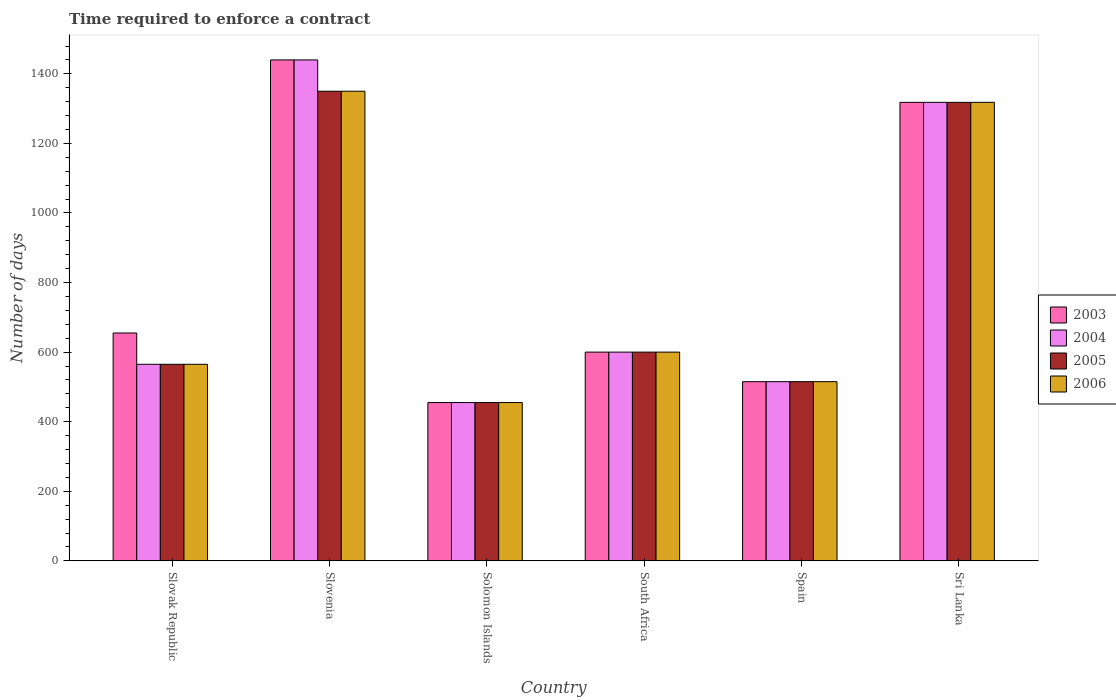Are the number of bars on each tick of the X-axis equal?
Make the answer very short. Yes. What is the label of the 4th group of bars from the left?
Offer a terse response. South Africa. In how many cases, is the number of bars for a given country not equal to the number of legend labels?
Make the answer very short. 0. What is the number of days required to enforce a contract in 2004 in Solomon Islands?
Your response must be concise. 455. Across all countries, what is the maximum number of days required to enforce a contract in 2003?
Offer a terse response. 1440. Across all countries, what is the minimum number of days required to enforce a contract in 2005?
Your answer should be compact. 455. In which country was the number of days required to enforce a contract in 2003 maximum?
Your answer should be very brief. Slovenia. In which country was the number of days required to enforce a contract in 2006 minimum?
Provide a succinct answer. Solomon Islands. What is the total number of days required to enforce a contract in 2004 in the graph?
Keep it short and to the point. 4893. What is the difference between the number of days required to enforce a contract in 2003 in Slovenia and that in South Africa?
Provide a succinct answer. 840. What is the difference between the number of days required to enforce a contract in 2005 in Sri Lanka and the number of days required to enforce a contract in 2004 in South Africa?
Make the answer very short. 718. What is the average number of days required to enforce a contract in 2004 per country?
Provide a short and direct response. 815.5. In how many countries, is the number of days required to enforce a contract in 2004 greater than 1360 days?
Offer a very short reply. 1. What is the ratio of the number of days required to enforce a contract in 2003 in Slovak Republic to that in South Africa?
Offer a very short reply. 1.09. Is the number of days required to enforce a contract in 2006 in South Africa less than that in Spain?
Offer a very short reply. No. Is the difference between the number of days required to enforce a contract in 2005 in Slovak Republic and Sri Lanka greater than the difference between the number of days required to enforce a contract in 2004 in Slovak Republic and Sri Lanka?
Make the answer very short. No. What is the difference between the highest and the second highest number of days required to enforce a contract in 2006?
Provide a succinct answer. 718. What is the difference between the highest and the lowest number of days required to enforce a contract in 2006?
Give a very brief answer. 895. Is the sum of the number of days required to enforce a contract in 2005 in Spain and Sri Lanka greater than the maximum number of days required to enforce a contract in 2003 across all countries?
Provide a succinct answer. Yes. Is it the case that in every country, the sum of the number of days required to enforce a contract in 2006 and number of days required to enforce a contract in 2005 is greater than the number of days required to enforce a contract in 2004?
Make the answer very short. Yes. How many countries are there in the graph?
Your answer should be compact. 6. What is the difference between two consecutive major ticks on the Y-axis?
Your answer should be very brief. 200. Are the values on the major ticks of Y-axis written in scientific E-notation?
Your answer should be compact. No. Where does the legend appear in the graph?
Give a very brief answer. Center right. How are the legend labels stacked?
Make the answer very short. Vertical. What is the title of the graph?
Offer a terse response. Time required to enforce a contract. What is the label or title of the X-axis?
Offer a terse response. Country. What is the label or title of the Y-axis?
Offer a very short reply. Number of days. What is the Number of days of 2003 in Slovak Republic?
Offer a very short reply. 655. What is the Number of days of 2004 in Slovak Republic?
Give a very brief answer. 565. What is the Number of days in 2005 in Slovak Republic?
Your response must be concise. 565. What is the Number of days of 2006 in Slovak Republic?
Give a very brief answer. 565. What is the Number of days of 2003 in Slovenia?
Offer a terse response. 1440. What is the Number of days of 2004 in Slovenia?
Give a very brief answer. 1440. What is the Number of days in 2005 in Slovenia?
Ensure brevity in your answer.  1350. What is the Number of days in 2006 in Slovenia?
Offer a terse response. 1350. What is the Number of days in 2003 in Solomon Islands?
Ensure brevity in your answer.  455. What is the Number of days in 2004 in Solomon Islands?
Give a very brief answer. 455. What is the Number of days of 2005 in Solomon Islands?
Ensure brevity in your answer.  455. What is the Number of days of 2006 in Solomon Islands?
Offer a terse response. 455. What is the Number of days of 2003 in South Africa?
Your answer should be very brief. 600. What is the Number of days of 2004 in South Africa?
Give a very brief answer. 600. What is the Number of days in 2005 in South Africa?
Make the answer very short. 600. What is the Number of days of 2006 in South Africa?
Keep it short and to the point. 600. What is the Number of days in 2003 in Spain?
Provide a succinct answer. 515. What is the Number of days in 2004 in Spain?
Provide a succinct answer. 515. What is the Number of days in 2005 in Spain?
Keep it short and to the point. 515. What is the Number of days of 2006 in Spain?
Make the answer very short. 515. What is the Number of days of 2003 in Sri Lanka?
Your response must be concise. 1318. What is the Number of days in 2004 in Sri Lanka?
Ensure brevity in your answer.  1318. What is the Number of days of 2005 in Sri Lanka?
Ensure brevity in your answer.  1318. What is the Number of days in 2006 in Sri Lanka?
Offer a very short reply. 1318. Across all countries, what is the maximum Number of days in 2003?
Keep it short and to the point. 1440. Across all countries, what is the maximum Number of days in 2004?
Provide a succinct answer. 1440. Across all countries, what is the maximum Number of days of 2005?
Make the answer very short. 1350. Across all countries, what is the maximum Number of days in 2006?
Ensure brevity in your answer.  1350. Across all countries, what is the minimum Number of days in 2003?
Offer a terse response. 455. Across all countries, what is the minimum Number of days of 2004?
Provide a short and direct response. 455. Across all countries, what is the minimum Number of days of 2005?
Your response must be concise. 455. Across all countries, what is the minimum Number of days of 2006?
Ensure brevity in your answer.  455. What is the total Number of days of 2003 in the graph?
Make the answer very short. 4983. What is the total Number of days in 2004 in the graph?
Offer a very short reply. 4893. What is the total Number of days of 2005 in the graph?
Your answer should be compact. 4803. What is the total Number of days in 2006 in the graph?
Ensure brevity in your answer.  4803. What is the difference between the Number of days of 2003 in Slovak Republic and that in Slovenia?
Keep it short and to the point. -785. What is the difference between the Number of days of 2004 in Slovak Republic and that in Slovenia?
Ensure brevity in your answer.  -875. What is the difference between the Number of days in 2005 in Slovak Republic and that in Slovenia?
Ensure brevity in your answer.  -785. What is the difference between the Number of days of 2006 in Slovak Republic and that in Slovenia?
Your response must be concise. -785. What is the difference between the Number of days in 2003 in Slovak Republic and that in Solomon Islands?
Keep it short and to the point. 200. What is the difference between the Number of days of 2004 in Slovak Republic and that in Solomon Islands?
Keep it short and to the point. 110. What is the difference between the Number of days in 2005 in Slovak Republic and that in Solomon Islands?
Your response must be concise. 110. What is the difference between the Number of days of 2006 in Slovak Republic and that in Solomon Islands?
Your answer should be very brief. 110. What is the difference between the Number of days of 2004 in Slovak Republic and that in South Africa?
Offer a very short reply. -35. What is the difference between the Number of days of 2005 in Slovak Republic and that in South Africa?
Offer a very short reply. -35. What is the difference between the Number of days in 2006 in Slovak Republic and that in South Africa?
Your answer should be compact. -35. What is the difference between the Number of days of 2003 in Slovak Republic and that in Spain?
Your answer should be compact. 140. What is the difference between the Number of days in 2005 in Slovak Republic and that in Spain?
Your answer should be compact. 50. What is the difference between the Number of days in 2006 in Slovak Republic and that in Spain?
Provide a short and direct response. 50. What is the difference between the Number of days of 2003 in Slovak Republic and that in Sri Lanka?
Give a very brief answer. -663. What is the difference between the Number of days in 2004 in Slovak Republic and that in Sri Lanka?
Ensure brevity in your answer.  -753. What is the difference between the Number of days of 2005 in Slovak Republic and that in Sri Lanka?
Ensure brevity in your answer.  -753. What is the difference between the Number of days in 2006 in Slovak Republic and that in Sri Lanka?
Provide a short and direct response. -753. What is the difference between the Number of days in 2003 in Slovenia and that in Solomon Islands?
Provide a succinct answer. 985. What is the difference between the Number of days of 2004 in Slovenia and that in Solomon Islands?
Offer a terse response. 985. What is the difference between the Number of days in 2005 in Slovenia and that in Solomon Islands?
Give a very brief answer. 895. What is the difference between the Number of days of 2006 in Slovenia and that in Solomon Islands?
Your answer should be very brief. 895. What is the difference between the Number of days of 2003 in Slovenia and that in South Africa?
Keep it short and to the point. 840. What is the difference between the Number of days in 2004 in Slovenia and that in South Africa?
Your response must be concise. 840. What is the difference between the Number of days in 2005 in Slovenia and that in South Africa?
Your answer should be compact. 750. What is the difference between the Number of days in 2006 in Slovenia and that in South Africa?
Give a very brief answer. 750. What is the difference between the Number of days in 2003 in Slovenia and that in Spain?
Ensure brevity in your answer.  925. What is the difference between the Number of days of 2004 in Slovenia and that in Spain?
Provide a short and direct response. 925. What is the difference between the Number of days of 2005 in Slovenia and that in Spain?
Your answer should be compact. 835. What is the difference between the Number of days in 2006 in Slovenia and that in Spain?
Your answer should be very brief. 835. What is the difference between the Number of days of 2003 in Slovenia and that in Sri Lanka?
Make the answer very short. 122. What is the difference between the Number of days of 2004 in Slovenia and that in Sri Lanka?
Offer a terse response. 122. What is the difference between the Number of days in 2005 in Slovenia and that in Sri Lanka?
Offer a very short reply. 32. What is the difference between the Number of days in 2003 in Solomon Islands and that in South Africa?
Offer a very short reply. -145. What is the difference between the Number of days of 2004 in Solomon Islands and that in South Africa?
Provide a short and direct response. -145. What is the difference between the Number of days in 2005 in Solomon Islands and that in South Africa?
Provide a succinct answer. -145. What is the difference between the Number of days in 2006 in Solomon Islands and that in South Africa?
Keep it short and to the point. -145. What is the difference between the Number of days of 2003 in Solomon Islands and that in Spain?
Offer a very short reply. -60. What is the difference between the Number of days in 2004 in Solomon Islands and that in Spain?
Offer a very short reply. -60. What is the difference between the Number of days in 2005 in Solomon Islands and that in Spain?
Your answer should be very brief. -60. What is the difference between the Number of days of 2006 in Solomon Islands and that in Spain?
Provide a short and direct response. -60. What is the difference between the Number of days of 2003 in Solomon Islands and that in Sri Lanka?
Your response must be concise. -863. What is the difference between the Number of days of 2004 in Solomon Islands and that in Sri Lanka?
Ensure brevity in your answer.  -863. What is the difference between the Number of days of 2005 in Solomon Islands and that in Sri Lanka?
Provide a short and direct response. -863. What is the difference between the Number of days in 2006 in Solomon Islands and that in Sri Lanka?
Keep it short and to the point. -863. What is the difference between the Number of days of 2006 in South Africa and that in Spain?
Make the answer very short. 85. What is the difference between the Number of days in 2003 in South Africa and that in Sri Lanka?
Make the answer very short. -718. What is the difference between the Number of days of 2004 in South Africa and that in Sri Lanka?
Ensure brevity in your answer.  -718. What is the difference between the Number of days of 2005 in South Africa and that in Sri Lanka?
Your answer should be compact. -718. What is the difference between the Number of days of 2006 in South Africa and that in Sri Lanka?
Ensure brevity in your answer.  -718. What is the difference between the Number of days of 2003 in Spain and that in Sri Lanka?
Provide a short and direct response. -803. What is the difference between the Number of days in 2004 in Spain and that in Sri Lanka?
Ensure brevity in your answer.  -803. What is the difference between the Number of days in 2005 in Spain and that in Sri Lanka?
Offer a terse response. -803. What is the difference between the Number of days of 2006 in Spain and that in Sri Lanka?
Your response must be concise. -803. What is the difference between the Number of days of 2003 in Slovak Republic and the Number of days of 2004 in Slovenia?
Keep it short and to the point. -785. What is the difference between the Number of days of 2003 in Slovak Republic and the Number of days of 2005 in Slovenia?
Your answer should be very brief. -695. What is the difference between the Number of days in 2003 in Slovak Republic and the Number of days in 2006 in Slovenia?
Ensure brevity in your answer.  -695. What is the difference between the Number of days of 2004 in Slovak Republic and the Number of days of 2005 in Slovenia?
Make the answer very short. -785. What is the difference between the Number of days in 2004 in Slovak Republic and the Number of days in 2006 in Slovenia?
Keep it short and to the point. -785. What is the difference between the Number of days in 2005 in Slovak Republic and the Number of days in 2006 in Slovenia?
Offer a terse response. -785. What is the difference between the Number of days of 2003 in Slovak Republic and the Number of days of 2004 in Solomon Islands?
Offer a very short reply. 200. What is the difference between the Number of days in 2003 in Slovak Republic and the Number of days in 2005 in Solomon Islands?
Offer a very short reply. 200. What is the difference between the Number of days in 2003 in Slovak Republic and the Number of days in 2006 in Solomon Islands?
Keep it short and to the point. 200. What is the difference between the Number of days in 2004 in Slovak Republic and the Number of days in 2005 in Solomon Islands?
Make the answer very short. 110. What is the difference between the Number of days in 2004 in Slovak Republic and the Number of days in 2006 in Solomon Islands?
Provide a succinct answer. 110. What is the difference between the Number of days of 2005 in Slovak Republic and the Number of days of 2006 in Solomon Islands?
Give a very brief answer. 110. What is the difference between the Number of days of 2003 in Slovak Republic and the Number of days of 2004 in South Africa?
Give a very brief answer. 55. What is the difference between the Number of days of 2003 in Slovak Republic and the Number of days of 2005 in South Africa?
Give a very brief answer. 55. What is the difference between the Number of days of 2004 in Slovak Republic and the Number of days of 2005 in South Africa?
Provide a succinct answer. -35. What is the difference between the Number of days of 2004 in Slovak Republic and the Number of days of 2006 in South Africa?
Provide a succinct answer. -35. What is the difference between the Number of days in 2005 in Slovak Republic and the Number of days in 2006 in South Africa?
Your answer should be compact. -35. What is the difference between the Number of days in 2003 in Slovak Republic and the Number of days in 2004 in Spain?
Your response must be concise. 140. What is the difference between the Number of days in 2003 in Slovak Republic and the Number of days in 2005 in Spain?
Offer a very short reply. 140. What is the difference between the Number of days in 2003 in Slovak Republic and the Number of days in 2006 in Spain?
Provide a short and direct response. 140. What is the difference between the Number of days of 2005 in Slovak Republic and the Number of days of 2006 in Spain?
Make the answer very short. 50. What is the difference between the Number of days of 2003 in Slovak Republic and the Number of days of 2004 in Sri Lanka?
Ensure brevity in your answer.  -663. What is the difference between the Number of days of 2003 in Slovak Republic and the Number of days of 2005 in Sri Lanka?
Your response must be concise. -663. What is the difference between the Number of days in 2003 in Slovak Republic and the Number of days in 2006 in Sri Lanka?
Provide a short and direct response. -663. What is the difference between the Number of days of 2004 in Slovak Republic and the Number of days of 2005 in Sri Lanka?
Provide a succinct answer. -753. What is the difference between the Number of days of 2004 in Slovak Republic and the Number of days of 2006 in Sri Lanka?
Provide a short and direct response. -753. What is the difference between the Number of days of 2005 in Slovak Republic and the Number of days of 2006 in Sri Lanka?
Offer a terse response. -753. What is the difference between the Number of days of 2003 in Slovenia and the Number of days of 2004 in Solomon Islands?
Offer a terse response. 985. What is the difference between the Number of days of 2003 in Slovenia and the Number of days of 2005 in Solomon Islands?
Make the answer very short. 985. What is the difference between the Number of days in 2003 in Slovenia and the Number of days in 2006 in Solomon Islands?
Your response must be concise. 985. What is the difference between the Number of days in 2004 in Slovenia and the Number of days in 2005 in Solomon Islands?
Ensure brevity in your answer.  985. What is the difference between the Number of days in 2004 in Slovenia and the Number of days in 2006 in Solomon Islands?
Your answer should be very brief. 985. What is the difference between the Number of days of 2005 in Slovenia and the Number of days of 2006 in Solomon Islands?
Provide a short and direct response. 895. What is the difference between the Number of days in 2003 in Slovenia and the Number of days in 2004 in South Africa?
Make the answer very short. 840. What is the difference between the Number of days in 2003 in Slovenia and the Number of days in 2005 in South Africa?
Offer a very short reply. 840. What is the difference between the Number of days of 2003 in Slovenia and the Number of days of 2006 in South Africa?
Give a very brief answer. 840. What is the difference between the Number of days of 2004 in Slovenia and the Number of days of 2005 in South Africa?
Your response must be concise. 840. What is the difference between the Number of days of 2004 in Slovenia and the Number of days of 2006 in South Africa?
Your answer should be compact. 840. What is the difference between the Number of days of 2005 in Slovenia and the Number of days of 2006 in South Africa?
Make the answer very short. 750. What is the difference between the Number of days in 2003 in Slovenia and the Number of days in 2004 in Spain?
Your response must be concise. 925. What is the difference between the Number of days of 2003 in Slovenia and the Number of days of 2005 in Spain?
Your answer should be very brief. 925. What is the difference between the Number of days of 2003 in Slovenia and the Number of days of 2006 in Spain?
Your answer should be very brief. 925. What is the difference between the Number of days of 2004 in Slovenia and the Number of days of 2005 in Spain?
Your response must be concise. 925. What is the difference between the Number of days of 2004 in Slovenia and the Number of days of 2006 in Spain?
Provide a succinct answer. 925. What is the difference between the Number of days of 2005 in Slovenia and the Number of days of 2006 in Spain?
Your answer should be very brief. 835. What is the difference between the Number of days in 2003 in Slovenia and the Number of days in 2004 in Sri Lanka?
Provide a short and direct response. 122. What is the difference between the Number of days in 2003 in Slovenia and the Number of days in 2005 in Sri Lanka?
Keep it short and to the point. 122. What is the difference between the Number of days in 2003 in Slovenia and the Number of days in 2006 in Sri Lanka?
Give a very brief answer. 122. What is the difference between the Number of days in 2004 in Slovenia and the Number of days in 2005 in Sri Lanka?
Ensure brevity in your answer.  122. What is the difference between the Number of days in 2004 in Slovenia and the Number of days in 2006 in Sri Lanka?
Make the answer very short. 122. What is the difference between the Number of days of 2005 in Slovenia and the Number of days of 2006 in Sri Lanka?
Ensure brevity in your answer.  32. What is the difference between the Number of days of 2003 in Solomon Islands and the Number of days of 2004 in South Africa?
Offer a terse response. -145. What is the difference between the Number of days of 2003 in Solomon Islands and the Number of days of 2005 in South Africa?
Give a very brief answer. -145. What is the difference between the Number of days of 2003 in Solomon Islands and the Number of days of 2006 in South Africa?
Give a very brief answer. -145. What is the difference between the Number of days of 2004 in Solomon Islands and the Number of days of 2005 in South Africa?
Offer a terse response. -145. What is the difference between the Number of days of 2004 in Solomon Islands and the Number of days of 2006 in South Africa?
Provide a short and direct response. -145. What is the difference between the Number of days in 2005 in Solomon Islands and the Number of days in 2006 in South Africa?
Your answer should be very brief. -145. What is the difference between the Number of days of 2003 in Solomon Islands and the Number of days of 2004 in Spain?
Give a very brief answer. -60. What is the difference between the Number of days in 2003 in Solomon Islands and the Number of days in 2005 in Spain?
Ensure brevity in your answer.  -60. What is the difference between the Number of days in 2003 in Solomon Islands and the Number of days in 2006 in Spain?
Your answer should be very brief. -60. What is the difference between the Number of days of 2004 in Solomon Islands and the Number of days of 2005 in Spain?
Give a very brief answer. -60. What is the difference between the Number of days in 2004 in Solomon Islands and the Number of days in 2006 in Spain?
Provide a succinct answer. -60. What is the difference between the Number of days in 2005 in Solomon Islands and the Number of days in 2006 in Spain?
Your answer should be compact. -60. What is the difference between the Number of days in 2003 in Solomon Islands and the Number of days in 2004 in Sri Lanka?
Make the answer very short. -863. What is the difference between the Number of days of 2003 in Solomon Islands and the Number of days of 2005 in Sri Lanka?
Provide a short and direct response. -863. What is the difference between the Number of days of 2003 in Solomon Islands and the Number of days of 2006 in Sri Lanka?
Your response must be concise. -863. What is the difference between the Number of days of 2004 in Solomon Islands and the Number of days of 2005 in Sri Lanka?
Provide a succinct answer. -863. What is the difference between the Number of days of 2004 in Solomon Islands and the Number of days of 2006 in Sri Lanka?
Offer a very short reply. -863. What is the difference between the Number of days in 2005 in Solomon Islands and the Number of days in 2006 in Sri Lanka?
Provide a succinct answer. -863. What is the difference between the Number of days of 2003 in South Africa and the Number of days of 2006 in Spain?
Provide a short and direct response. 85. What is the difference between the Number of days in 2004 in South Africa and the Number of days in 2005 in Spain?
Make the answer very short. 85. What is the difference between the Number of days of 2004 in South Africa and the Number of days of 2006 in Spain?
Offer a terse response. 85. What is the difference between the Number of days in 2003 in South Africa and the Number of days in 2004 in Sri Lanka?
Provide a short and direct response. -718. What is the difference between the Number of days in 2003 in South Africa and the Number of days in 2005 in Sri Lanka?
Provide a succinct answer. -718. What is the difference between the Number of days in 2003 in South Africa and the Number of days in 2006 in Sri Lanka?
Offer a very short reply. -718. What is the difference between the Number of days in 2004 in South Africa and the Number of days in 2005 in Sri Lanka?
Keep it short and to the point. -718. What is the difference between the Number of days in 2004 in South Africa and the Number of days in 2006 in Sri Lanka?
Your response must be concise. -718. What is the difference between the Number of days in 2005 in South Africa and the Number of days in 2006 in Sri Lanka?
Give a very brief answer. -718. What is the difference between the Number of days in 2003 in Spain and the Number of days in 2004 in Sri Lanka?
Give a very brief answer. -803. What is the difference between the Number of days in 2003 in Spain and the Number of days in 2005 in Sri Lanka?
Provide a short and direct response. -803. What is the difference between the Number of days in 2003 in Spain and the Number of days in 2006 in Sri Lanka?
Ensure brevity in your answer.  -803. What is the difference between the Number of days in 2004 in Spain and the Number of days in 2005 in Sri Lanka?
Your answer should be compact. -803. What is the difference between the Number of days in 2004 in Spain and the Number of days in 2006 in Sri Lanka?
Offer a terse response. -803. What is the difference between the Number of days of 2005 in Spain and the Number of days of 2006 in Sri Lanka?
Provide a short and direct response. -803. What is the average Number of days in 2003 per country?
Give a very brief answer. 830.5. What is the average Number of days in 2004 per country?
Provide a short and direct response. 815.5. What is the average Number of days in 2005 per country?
Your answer should be very brief. 800.5. What is the average Number of days of 2006 per country?
Provide a short and direct response. 800.5. What is the difference between the Number of days of 2003 and Number of days of 2004 in Slovak Republic?
Your answer should be compact. 90. What is the difference between the Number of days of 2004 and Number of days of 2005 in Slovak Republic?
Provide a succinct answer. 0. What is the difference between the Number of days of 2004 and Number of days of 2006 in Slovak Republic?
Provide a succinct answer. 0. What is the difference between the Number of days in 2005 and Number of days in 2006 in Slovak Republic?
Ensure brevity in your answer.  0. What is the difference between the Number of days of 2003 and Number of days of 2004 in Slovenia?
Keep it short and to the point. 0. What is the difference between the Number of days of 2004 and Number of days of 2005 in Slovenia?
Ensure brevity in your answer.  90. What is the difference between the Number of days of 2005 and Number of days of 2006 in Slovenia?
Provide a succinct answer. 0. What is the difference between the Number of days of 2003 and Number of days of 2004 in Solomon Islands?
Make the answer very short. 0. What is the difference between the Number of days in 2003 and Number of days in 2005 in Solomon Islands?
Make the answer very short. 0. What is the difference between the Number of days in 2005 and Number of days in 2006 in Solomon Islands?
Your response must be concise. 0. What is the difference between the Number of days of 2003 and Number of days of 2006 in South Africa?
Offer a terse response. 0. What is the difference between the Number of days of 2004 and Number of days of 2005 in South Africa?
Your answer should be compact. 0. What is the difference between the Number of days in 2004 and Number of days in 2006 in South Africa?
Offer a very short reply. 0. What is the difference between the Number of days in 2004 and Number of days in 2005 in Spain?
Provide a succinct answer. 0. What is the difference between the Number of days of 2004 and Number of days of 2006 in Spain?
Provide a short and direct response. 0. What is the difference between the Number of days of 2005 and Number of days of 2006 in Spain?
Ensure brevity in your answer.  0. What is the difference between the Number of days in 2003 and Number of days in 2006 in Sri Lanka?
Make the answer very short. 0. What is the difference between the Number of days in 2004 and Number of days in 2005 in Sri Lanka?
Provide a short and direct response. 0. What is the difference between the Number of days in 2005 and Number of days in 2006 in Sri Lanka?
Give a very brief answer. 0. What is the ratio of the Number of days of 2003 in Slovak Republic to that in Slovenia?
Ensure brevity in your answer.  0.45. What is the ratio of the Number of days of 2004 in Slovak Republic to that in Slovenia?
Your answer should be very brief. 0.39. What is the ratio of the Number of days of 2005 in Slovak Republic to that in Slovenia?
Keep it short and to the point. 0.42. What is the ratio of the Number of days of 2006 in Slovak Republic to that in Slovenia?
Keep it short and to the point. 0.42. What is the ratio of the Number of days of 2003 in Slovak Republic to that in Solomon Islands?
Your answer should be compact. 1.44. What is the ratio of the Number of days of 2004 in Slovak Republic to that in Solomon Islands?
Keep it short and to the point. 1.24. What is the ratio of the Number of days of 2005 in Slovak Republic to that in Solomon Islands?
Provide a succinct answer. 1.24. What is the ratio of the Number of days in 2006 in Slovak Republic to that in Solomon Islands?
Provide a succinct answer. 1.24. What is the ratio of the Number of days in 2003 in Slovak Republic to that in South Africa?
Offer a terse response. 1.09. What is the ratio of the Number of days of 2004 in Slovak Republic to that in South Africa?
Make the answer very short. 0.94. What is the ratio of the Number of days of 2005 in Slovak Republic to that in South Africa?
Ensure brevity in your answer.  0.94. What is the ratio of the Number of days of 2006 in Slovak Republic to that in South Africa?
Ensure brevity in your answer.  0.94. What is the ratio of the Number of days in 2003 in Slovak Republic to that in Spain?
Make the answer very short. 1.27. What is the ratio of the Number of days in 2004 in Slovak Republic to that in Spain?
Ensure brevity in your answer.  1.1. What is the ratio of the Number of days in 2005 in Slovak Republic to that in Spain?
Make the answer very short. 1.1. What is the ratio of the Number of days of 2006 in Slovak Republic to that in Spain?
Ensure brevity in your answer.  1.1. What is the ratio of the Number of days of 2003 in Slovak Republic to that in Sri Lanka?
Give a very brief answer. 0.5. What is the ratio of the Number of days of 2004 in Slovak Republic to that in Sri Lanka?
Ensure brevity in your answer.  0.43. What is the ratio of the Number of days of 2005 in Slovak Republic to that in Sri Lanka?
Make the answer very short. 0.43. What is the ratio of the Number of days in 2006 in Slovak Republic to that in Sri Lanka?
Provide a succinct answer. 0.43. What is the ratio of the Number of days in 2003 in Slovenia to that in Solomon Islands?
Make the answer very short. 3.16. What is the ratio of the Number of days of 2004 in Slovenia to that in Solomon Islands?
Provide a succinct answer. 3.16. What is the ratio of the Number of days of 2005 in Slovenia to that in Solomon Islands?
Ensure brevity in your answer.  2.97. What is the ratio of the Number of days in 2006 in Slovenia to that in Solomon Islands?
Keep it short and to the point. 2.97. What is the ratio of the Number of days of 2004 in Slovenia to that in South Africa?
Your answer should be compact. 2.4. What is the ratio of the Number of days of 2005 in Slovenia to that in South Africa?
Your response must be concise. 2.25. What is the ratio of the Number of days in 2006 in Slovenia to that in South Africa?
Your answer should be very brief. 2.25. What is the ratio of the Number of days of 2003 in Slovenia to that in Spain?
Provide a short and direct response. 2.8. What is the ratio of the Number of days of 2004 in Slovenia to that in Spain?
Your response must be concise. 2.8. What is the ratio of the Number of days of 2005 in Slovenia to that in Spain?
Your answer should be compact. 2.62. What is the ratio of the Number of days in 2006 in Slovenia to that in Spain?
Provide a short and direct response. 2.62. What is the ratio of the Number of days of 2003 in Slovenia to that in Sri Lanka?
Give a very brief answer. 1.09. What is the ratio of the Number of days in 2004 in Slovenia to that in Sri Lanka?
Provide a succinct answer. 1.09. What is the ratio of the Number of days in 2005 in Slovenia to that in Sri Lanka?
Provide a succinct answer. 1.02. What is the ratio of the Number of days in 2006 in Slovenia to that in Sri Lanka?
Provide a short and direct response. 1.02. What is the ratio of the Number of days of 2003 in Solomon Islands to that in South Africa?
Provide a short and direct response. 0.76. What is the ratio of the Number of days of 2004 in Solomon Islands to that in South Africa?
Provide a short and direct response. 0.76. What is the ratio of the Number of days in 2005 in Solomon Islands to that in South Africa?
Offer a terse response. 0.76. What is the ratio of the Number of days in 2006 in Solomon Islands to that in South Africa?
Offer a terse response. 0.76. What is the ratio of the Number of days in 2003 in Solomon Islands to that in Spain?
Keep it short and to the point. 0.88. What is the ratio of the Number of days of 2004 in Solomon Islands to that in Spain?
Your answer should be very brief. 0.88. What is the ratio of the Number of days in 2005 in Solomon Islands to that in Spain?
Offer a terse response. 0.88. What is the ratio of the Number of days of 2006 in Solomon Islands to that in Spain?
Offer a very short reply. 0.88. What is the ratio of the Number of days in 2003 in Solomon Islands to that in Sri Lanka?
Provide a succinct answer. 0.35. What is the ratio of the Number of days of 2004 in Solomon Islands to that in Sri Lanka?
Offer a terse response. 0.35. What is the ratio of the Number of days in 2005 in Solomon Islands to that in Sri Lanka?
Provide a short and direct response. 0.35. What is the ratio of the Number of days of 2006 in Solomon Islands to that in Sri Lanka?
Provide a succinct answer. 0.35. What is the ratio of the Number of days of 2003 in South Africa to that in Spain?
Provide a succinct answer. 1.17. What is the ratio of the Number of days of 2004 in South Africa to that in Spain?
Your response must be concise. 1.17. What is the ratio of the Number of days in 2005 in South Africa to that in Spain?
Ensure brevity in your answer.  1.17. What is the ratio of the Number of days of 2006 in South Africa to that in Spain?
Keep it short and to the point. 1.17. What is the ratio of the Number of days of 2003 in South Africa to that in Sri Lanka?
Provide a succinct answer. 0.46. What is the ratio of the Number of days of 2004 in South Africa to that in Sri Lanka?
Provide a succinct answer. 0.46. What is the ratio of the Number of days of 2005 in South Africa to that in Sri Lanka?
Provide a succinct answer. 0.46. What is the ratio of the Number of days of 2006 in South Africa to that in Sri Lanka?
Make the answer very short. 0.46. What is the ratio of the Number of days of 2003 in Spain to that in Sri Lanka?
Offer a terse response. 0.39. What is the ratio of the Number of days of 2004 in Spain to that in Sri Lanka?
Ensure brevity in your answer.  0.39. What is the ratio of the Number of days in 2005 in Spain to that in Sri Lanka?
Offer a very short reply. 0.39. What is the ratio of the Number of days in 2006 in Spain to that in Sri Lanka?
Make the answer very short. 0.39. What is the difference between the highest and the second highest Number of days of 2003?
Offer a terse response. 122. What is the difference between the highest and the second highest Number of days in 2004?
Offer a very short reply. 122. What is the difference between the highest and the lowest Number of days of 2003?
Offer a terse response. 985. What is the difference between the highest and the lowest Number of days of 2004?
Provide a short and direct response. 985. What is the difference between the highest and the lowest Number of days of 2005?
Ensure brevity in your answer.  895. What is the difference between the highest and the lowest Number of days of 2006?
Ensure brevity in your answer.  895. 